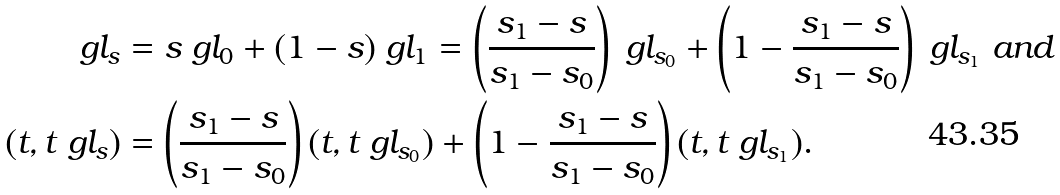Convert formula to latex. <formula><loc_0><loc_0><loc_500><loc_500>\ g l _ { s } & = s \ g l _ { 0 } + ( 1 - s ) \ g l _ { 1 } = \left ( \frac { s _ { 1 } - s } { s _ { 1 } - s _ { 0 } } \right ) \ g l _ { s _ { 0 } } + \left ( 1 - \frac { s _ { 1 } - s } { s _ { 1 } - s _ { 0 } } \right ) \ g l _ { s _ { 1 } } \text { and } \\ ( t , t \ g l _ { s } ) & = \left ( \frac { s _ { 1 } - s } { s _ { 1 } - s _ { 0 } } \right ) ( t , t \ g l _ { s _ { 0 } } ) + \left ( 1 - \frac { s _ { 1 } - s } { s _ { 1 } - s _ { 0 } } \right ) ( t , t \ g l _ { s _ { 1 } } ) . \\</formula> 